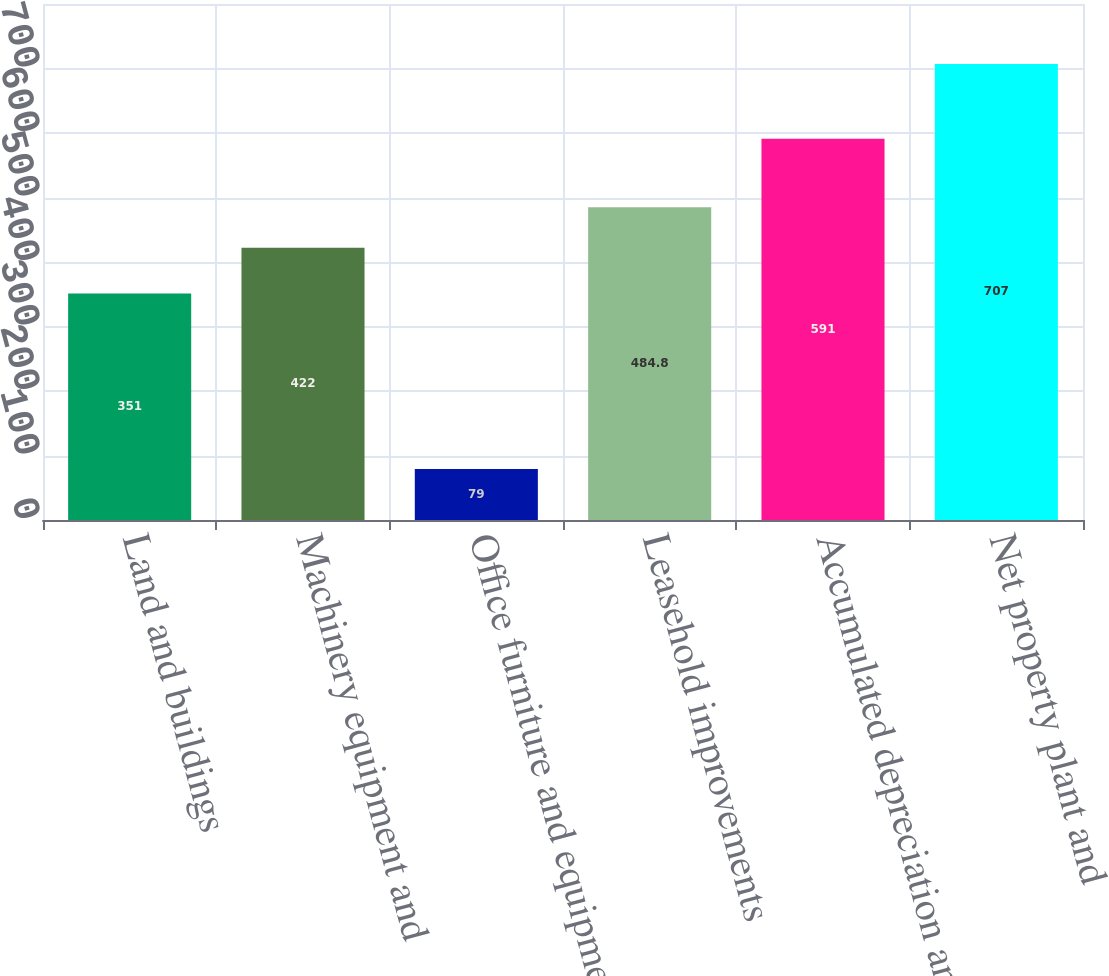<chart> <loc_0><loc_0><loc_500><loc_500><bar_chart><fcel>Land and buildings<fcel>Machinery equipment and<fcel>Office furniture and equipment<fcel>Leasehold improvements<fcel>Accumulated depreciation and<fcel>Net property plant and<nl><fcel>351<fcel>422<fcel>79<fcel>484.8<fcel>591<fcel>707<nl></chart> 